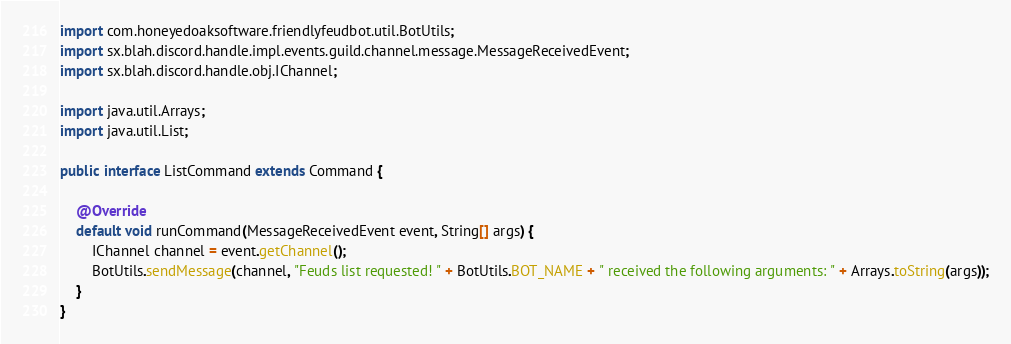Convert code to text. <code><loc_0><loc_0><loc_500><loc_500><_Java_>import com.honeyedoaksoftware.friendlyfeudbot.util.BotUtils;
import sx.blah.discord.handle.impl.events.guild.channel.message.MessageReceivedEvent;
import sx.blah.discord.handle.obj.IChannel;

import java.util.Arrays;
import java.util.List;

public interface ListCommand extends Command {

    @Override
    default void runCommand(MessageReceivedEvent event, String[] args) {
        IChannel channel = event.getChannel();
        BotUtils.sendMessage(channel, "Feuds list requested! " + BotUtils.BOT_NAME + " received the following arguments: " + Arrays.toString(args));
    }
}
</code> 